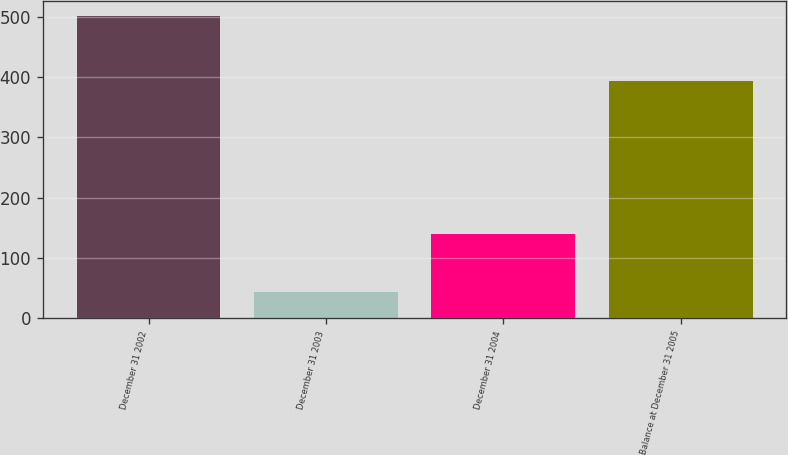Convert chart. <chart><loc_0><loc_0><loc_500><loc_500><bar_chart><fcel>December 31 2002<fcel>December 31 2003<fcel>December 31 2004<fcel>Balance at December 31 2005<nl><fcel>502<fcel>43<fcel>139<fcel>394<nl></chart> 